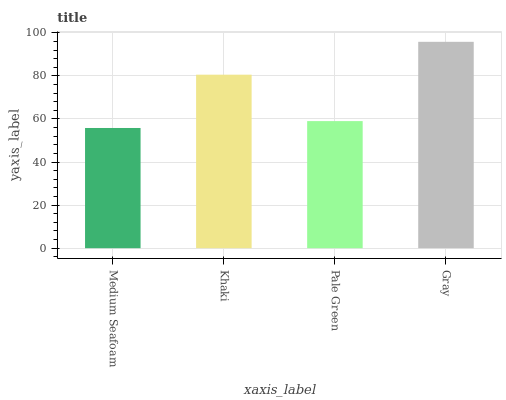Is Medium Seafoam the minimum?
Answer yes or no. Yes. Is Gray the maximum?
Answer yes or no. Yes. Is Khaki the minimum?
Answer yes or no. No. Is Khaki the maximum?
Answer yes or no. No. Is Khaki greater than Medium Seafoam?
Answer yes or no. Yes. Is Medium Seafoam less than Khaki?
Answer yes or no. Yes. Is Medium Seafoam greater than Khaki?
Answer yes or no. No. Is Khaki less than Medium Seafoam?
Answer yes or no. No. Is Khaki the high median?
Answer yes or no. Yes. Is Pale Green the low median?
Answer yes or no. Yes. Is Gray the high median?
Answer yes or no. No. Is Khaki the low median?
Answer yes or no. No. 